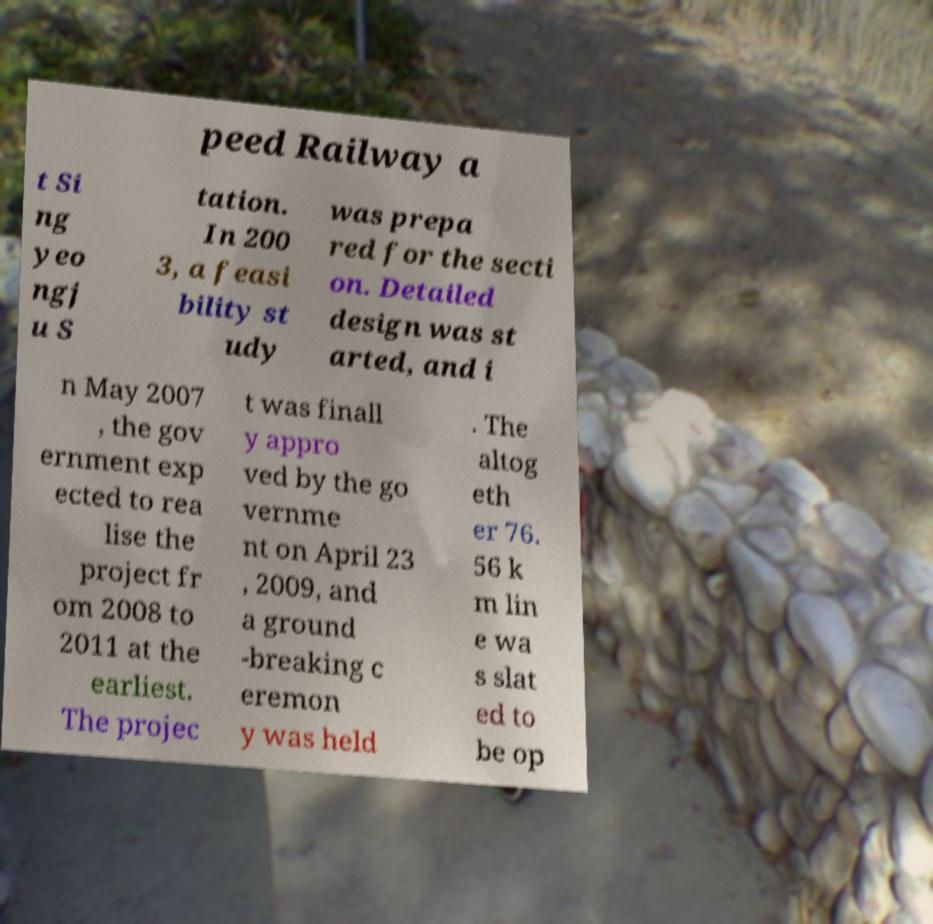There's text embedded in this image that I need extracted. Can you transcribe it verbatim? peed Railway a t Si ng yeo ngj u S tation. In 200 3, a feasi bility st udy was prepa red for the secti on. Detailed design was st arted, and i n May 2007 , the gov ernment exp ected to rea lise the project fr om 2008 to 2011 at the earliest. The projec t was finall y appro ved by the go vernme nt on April 23 , 2009, and a ground -breaking c eremon y was held . The altog eth er 76. 56 k m lin e wa s slat ed to be op 